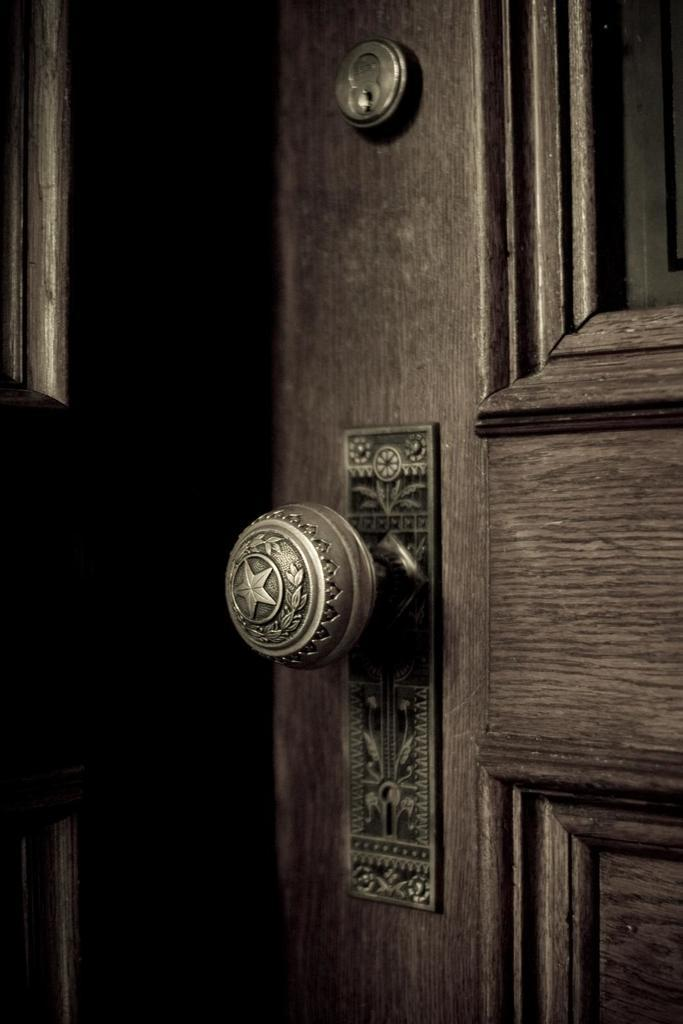What type of door is visible in the image? There is a brown door in the image. What features can be seen on the door? The door has a door knob and a door locker. How many birds are sitting on the door locker in the image? There are no birds present in the image; it only features a brown door with a door knob and door locker. 